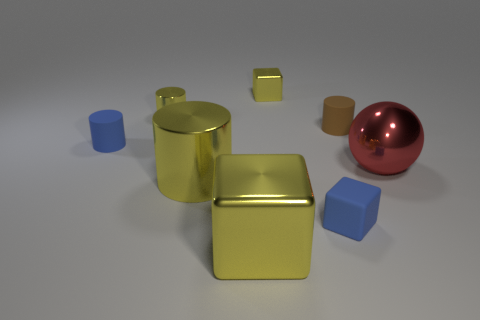Add 2 big yellow shiny objects. How many objects exist? 10 Subtract all blue cubes. How many cubes are left? 2 Subtract all red cylinders. How many yellow blocks are left? 2 Subtract all yellow blocks. How many blocks are left? 1 Subtract 3 cylinders. How many cylinders are left? 1 Subtract all gray blocks. Subtract all purple spheres. How many blocks are left? 3 Subtract all large cylinders. Subtract all brown things. How many objects are left? 6 Add 8 red metallic objects. How many red metallic objects are left? 9 Add 4 tiny yellow shiny objects. How many tiny yellow shiny objects exist? 6 Subtract 0 cyan blocks. How many objects are left? 8 